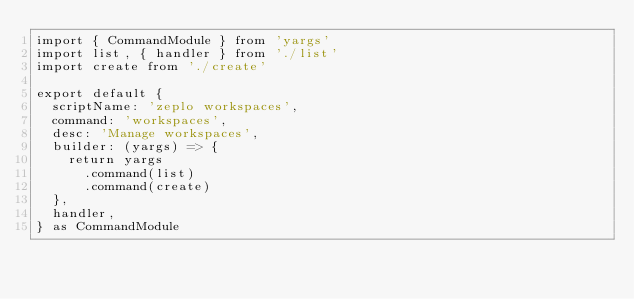<code> <loc_0><loc_0><loc_500><loc_500><_TypeScript_>import { CommandModule } from 'yargs'
import list, { handler } from './list'
import create from './create'

export default {
  scriptName: 'zeplo workspaces',
  command: 'workspaces',
  desc: 'Manage workspaces',
  builder: (yargs) => {
    return yargs
      .command(list)
      .command(create)
  },
  handler,
} as CommandModule
</code> 